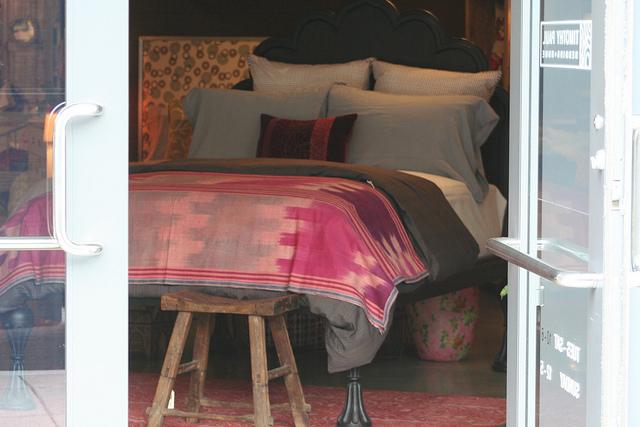Is this someone's bedroom?
Concise answer only. Yes. Is the door open or closed?
Short answer required. Open. Could the beds metal leg be broken?
Keep it brief. Yes. 